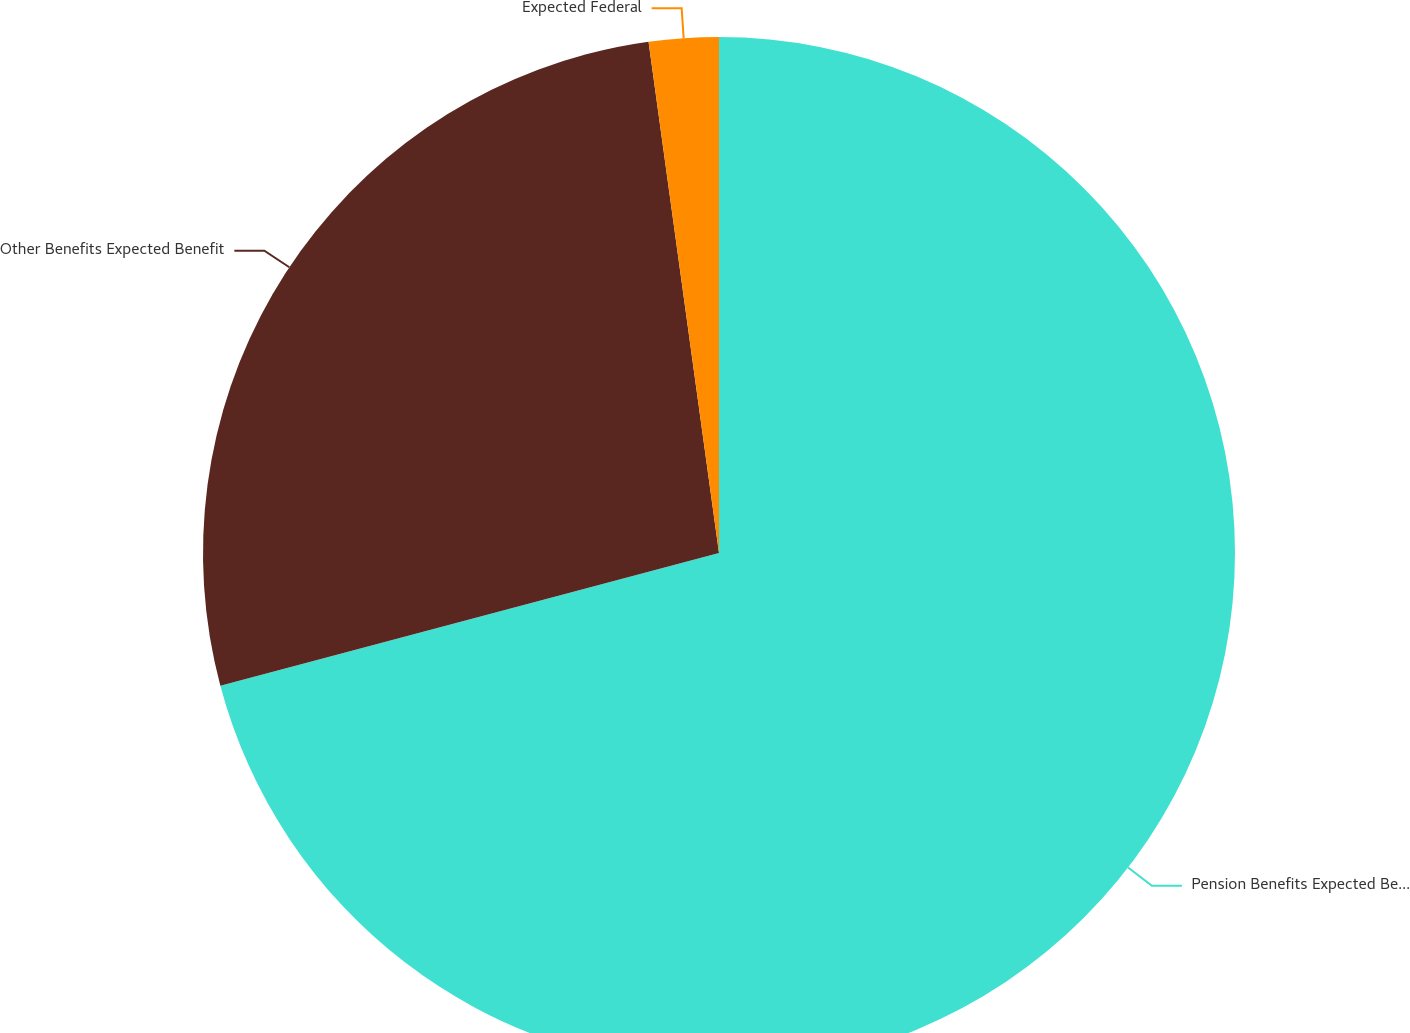Convert chart. <chart><loc_0><loc_0><loc_500><loc_500><pie_chart><fcel>Pension Benefits Expected Benefit<fcel>Other Benefits Expected Benefit<fcel>Expected Federal<nl><fcel>70.86%<fcel>26.96%<fcel>2.18%<nl></chart> 